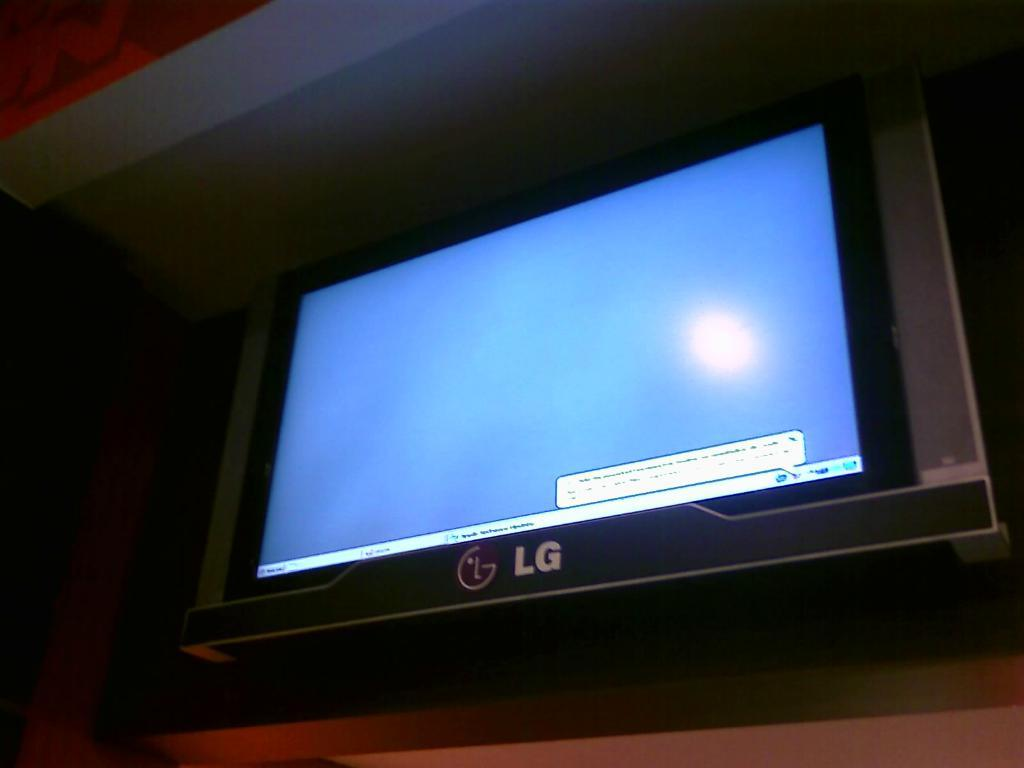<image>
Give a short and clear explanation of the subsequent image. A large LG monitor with a blue screen. 